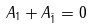Convert formula to latex. <formula><loc_0><loc_0><loc_500><loc_500>A _ { 1 } + A _ { \bar { 1 } } = 0</formula> 